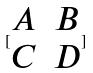<formula> <loc_0><loc_0><loc_500><loc_500>[ \begin{matrix} A & B \\ C & D \\ \end{matrix} ]</formula> 